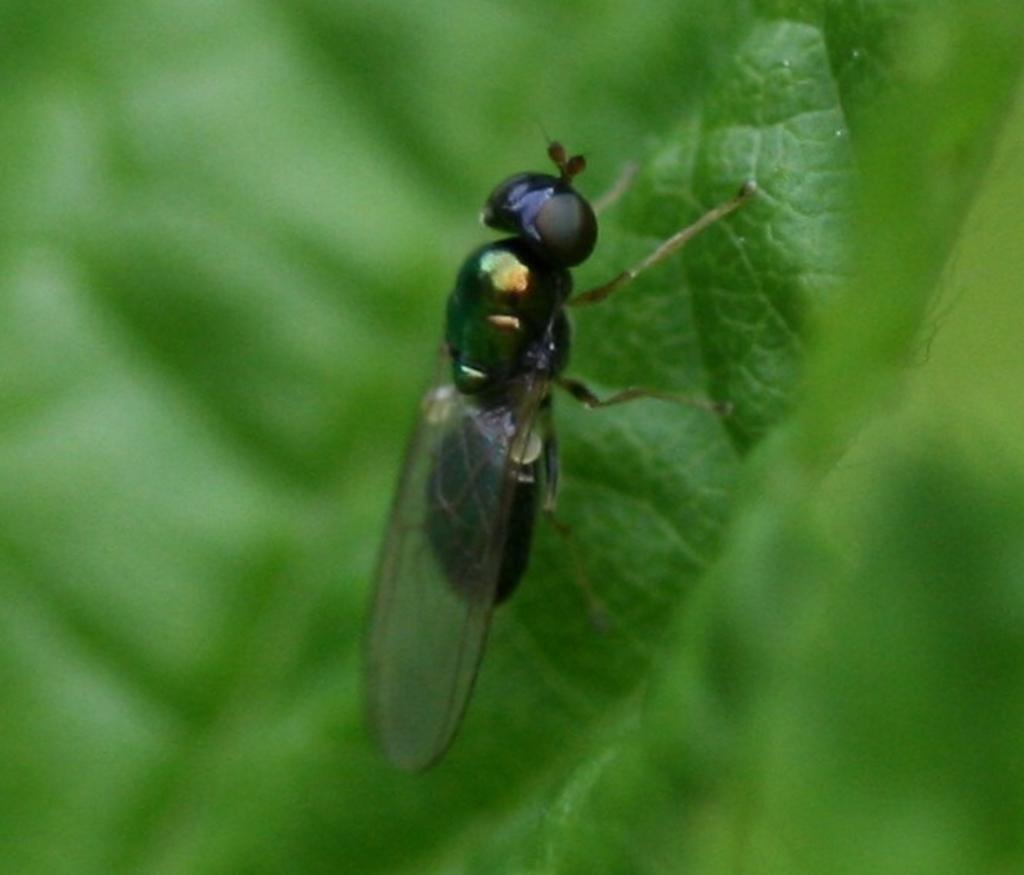What is present on the leaf in the image? There is a fly on a leaf in the image. What color is the crayon used to draw the fly on the leaf in the image? There is no crayon or drawing present in the image; it is a photograph of a real fly on a leaf. 